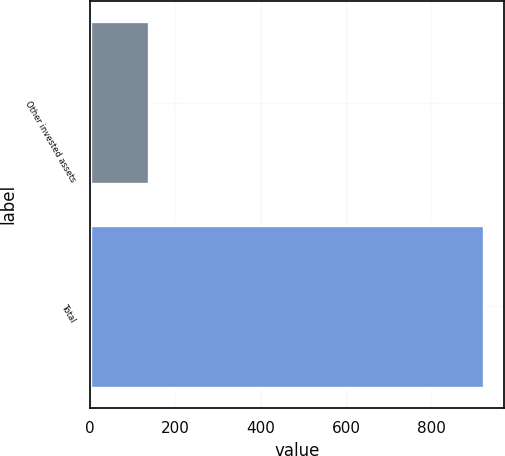Convert chart to OTSL. <chart><loc_0><loc_0><loc_500><loc_500><bar_chart><fcel>Other invested assets<fcel>Total<nl><fcel>139<fcel>923<nl></chart> 